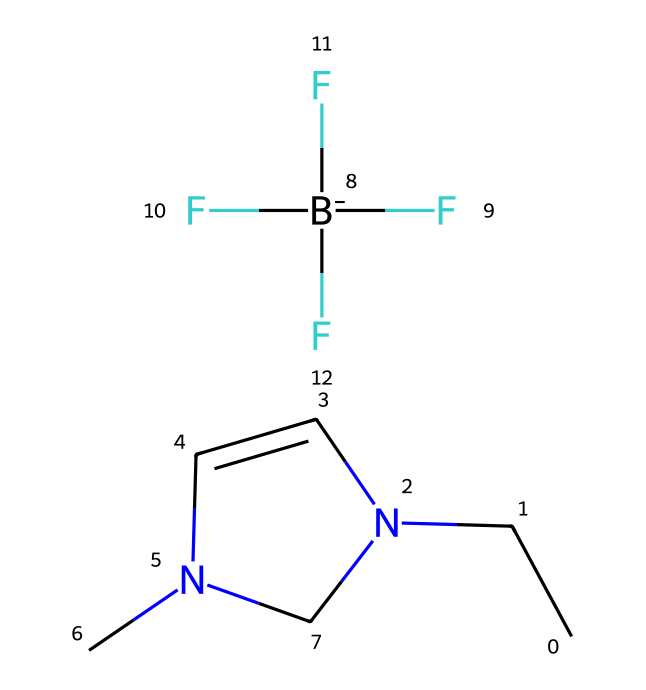What is the main anion in this ionic liquid? The SMILES representation reveals the presence of a distinct anion, which is a tetrafluoroborate represented by the "[B-](F)(F)(F)F" notation indicating one boron atom bonded to four fluorine atoms.
Answer: tetrafluoroborate How many nitrogen atoms are present in the structure? By analyzing the SMILES, we find that there are two nitrogen atoms indicated by "N" in the ring and the side chain structure.
Answer: two What kind of bonds are primarily present in ionic liquids like this one? Ionic liquids characteristically feature ionic bonds due to the interaction between the charged species, as seen in the tetrafluoroborate anion and the organic cation.
Answer: ionic bonds What is the cation's basic structure in this ionic liquid? The cation can be determined from the "CCN1C=CN(C)C1" part of the SMILES, which shows a cyclic structure incorporating nitrogen atoms, typical for cationic components in ionic liquids.
Answer: cyclic organic cation What functional group is present in the cation portion of this ionic liquid? The presence of the amine functionality is derived from the "N" within the "CCN" portion, indicating that it is a part of a nitrogen-containing base, characteristic of ionic liquids.
Answer: amine What role does the fluorinated anion play in this ionic liquid? The fluorinated anion stabilizes the ionic liquid structure and influences its properties such as solubility and conductivity due to the highly electronegative fluorine atoms.
Answer: stabilizes properties 